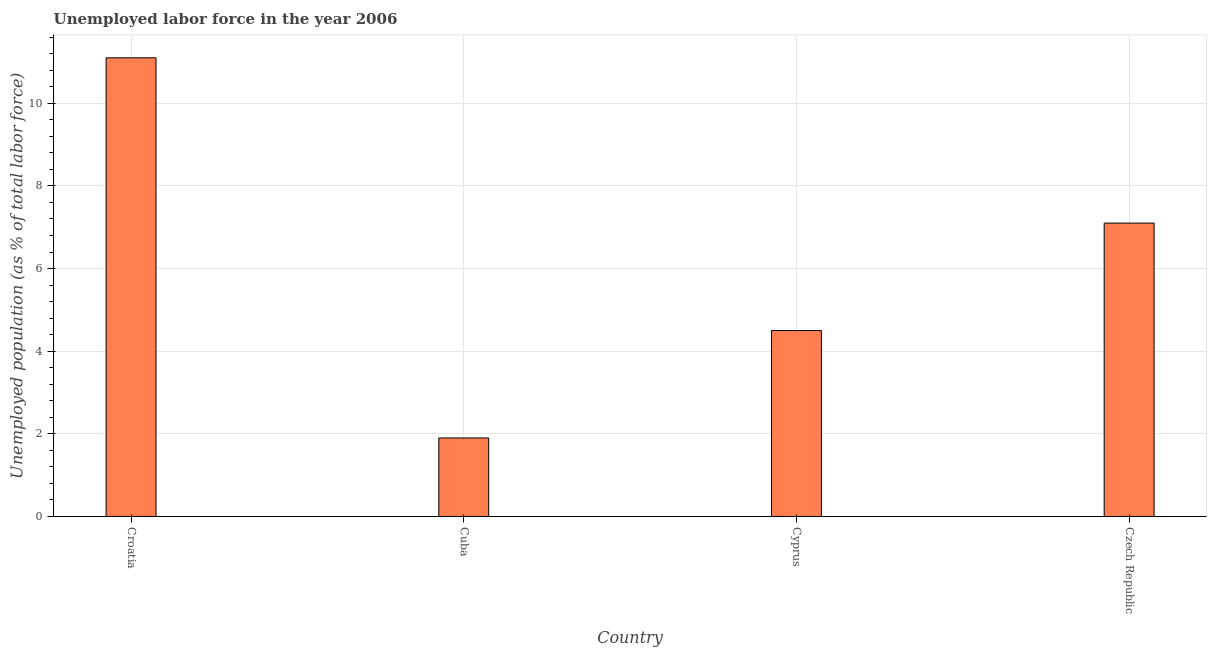Does the graph contain any zero values?
Offer a terse response. No. What is the title of the graph?
Offer a very short reply. Unemployed labor force in the year 2006. What is the label or title of the X-axis?
Your answer should be compact. Country. What is the label or title of the Y-axis?
Offer a terse response. Unemployed population (as % of total labor force). What is the total unemployed population in Cuba?
Your answer should be very brief. 1.9. Across all countries, what is the maximum total unemployed population?
Provide a short and direct response. 11.1. Across all countries, what is the minimum total unemployed population?
Provide a succinct answer. 1.9. In which country was the total unemployed population maximum?
Your answer should be compact. Croatia. In which country was the total unemployed population minimum?
Keep it short and to the point. Cuba. What is the sum of the total unemployed population?
Provide a short and direct response. 24.6. What is the difference between the total unemployed population in Croatia and Czech Republic?
Offer a terse response. 4. What is the average total unemployed population per country?
Provide a short and direct response. 6.15. What is the median total unemployed population?
Offer a terse response. 5.8. What is the ratio of the total unemployed population in Cyprus to that in Czech Republic?
Ensure brevity in your answer.  0.63. Is the difference between the total unemployed population in Croatia and Czech Republic greater than the difference between any two countries?
Your answer should be very brief. No. What is the difference between the highest and the second highest total unemployed population?
Keep it short and to the point. 4. Is the sum of the total unemployed population in Croatia and Czech Republic greater than the maximum total unemployed population across all countries?
Offer a very short reply. Yes. What is the difference between the highest and the lowest total unemployed population?
Your response must be concise. 9.2. What is the difference between two consecutive major ticks on the Y-axis?
Ensure brevity in your answer.  2. Are the values on the major ticks of Y-axis written in scientific E-notation?
Ensure brevity in your answer.  No. What is the Unemployed population (as % of total labor force) of Croatia?
Make the answer very short. 11.1. What is the Unemployed population (as % of total labor force) in Cuba?
Give a very brief answer. 1.9. What is the Unemployed population (as % of total labor force) in Czech Republic?
Offer a terse response. 7.1. What is the difference between the Unemployed population (as % of total labor force) in Croatia and Czech Republic?
Your answer should be compact. 4. What is the difference between the Unemployed population (as % of total labor force) in Cuba and Czech Republic?
Keep it short and to the point. -5.2. What is the ratio of the Unemployed population (as % of total labor force) in Croatia to that in Cuba?
Offer a very short reply. 5.84. What is the ratio of the Unemployed population (as % of total labor force) in Croatia to that in Cyprus?
Provide a succinct answer. 2.47. What is the ratio of the Unemployed population (as % of total labor force) in Croatia to that in Czech Republic?
Your answer should be compact. 1.56. What is the ratio of the Unemployed population (as % of total labor force) in Cuba to that in Cyprus?
Provide a short and direct response. 0.42. What is the ratio of the Unemployed population (as % of total labor force) in Cuba to that in Czech Republic?
Keep it short and to the point. 0.27. What is the ratio of the Unemployed population (as % of total labor force) in Cyprus to that in Czech Republic?
Your answer should be compact. 0.63. 